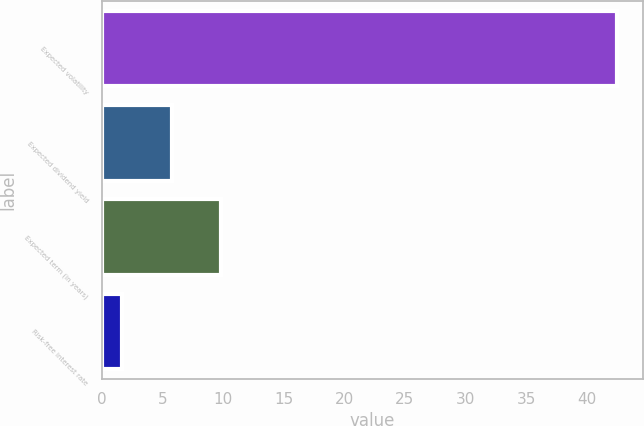<chart> <loc_0><loc_0><loc_500><loc_500><bar_chart><fcel>Expected volatility<fcel>Expected dividend yield<fcel>Expected term (in years)<fcel>Risk-free interest rate<nl><fcel>42.54<fcel>5.74<fcel>9.83<fcel>1.65<nl></chart> 